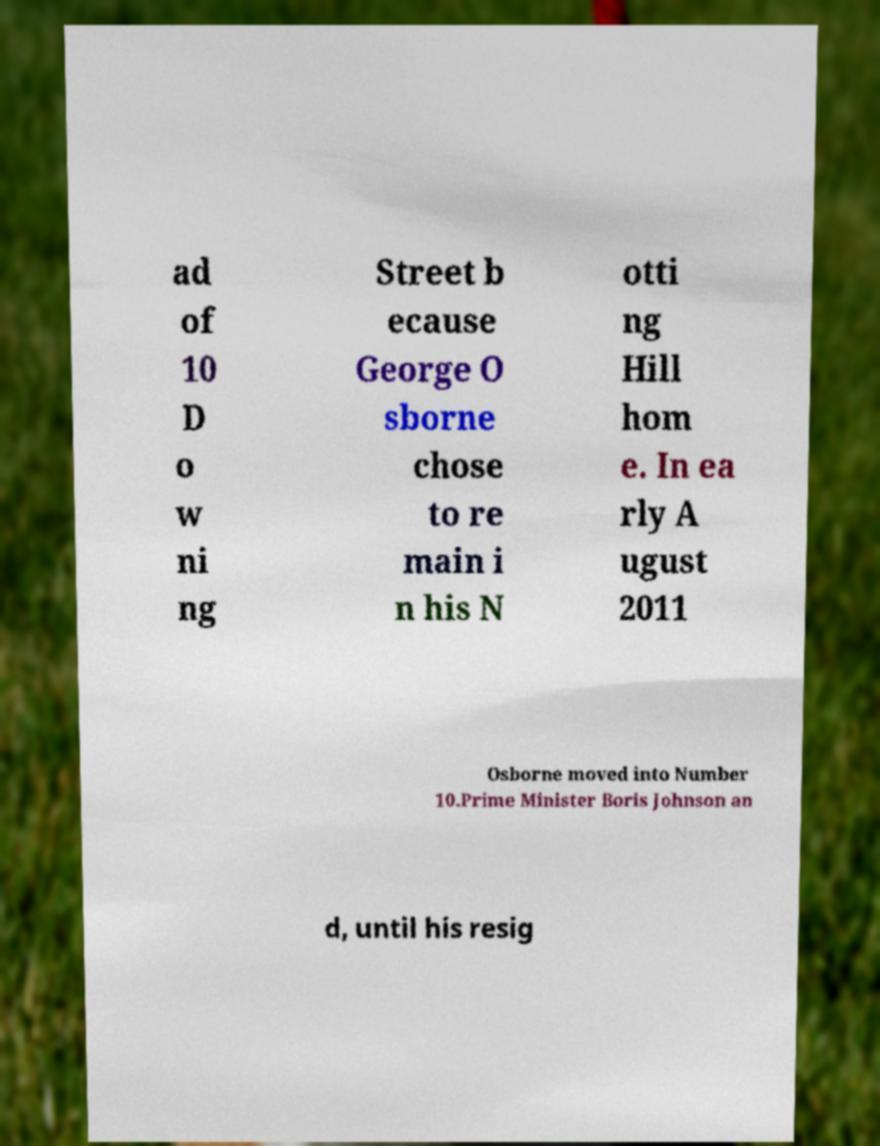Please identify and transcribe the text found in this image. ad of 10 D o w ni ng Street b ecause George O sborne chose to re main i n his N otti ng Hill hom e. In ea rly A ugust 2011 Osborne moved into Number 10.Prime Minister Boris Johnson an d, until his resig 